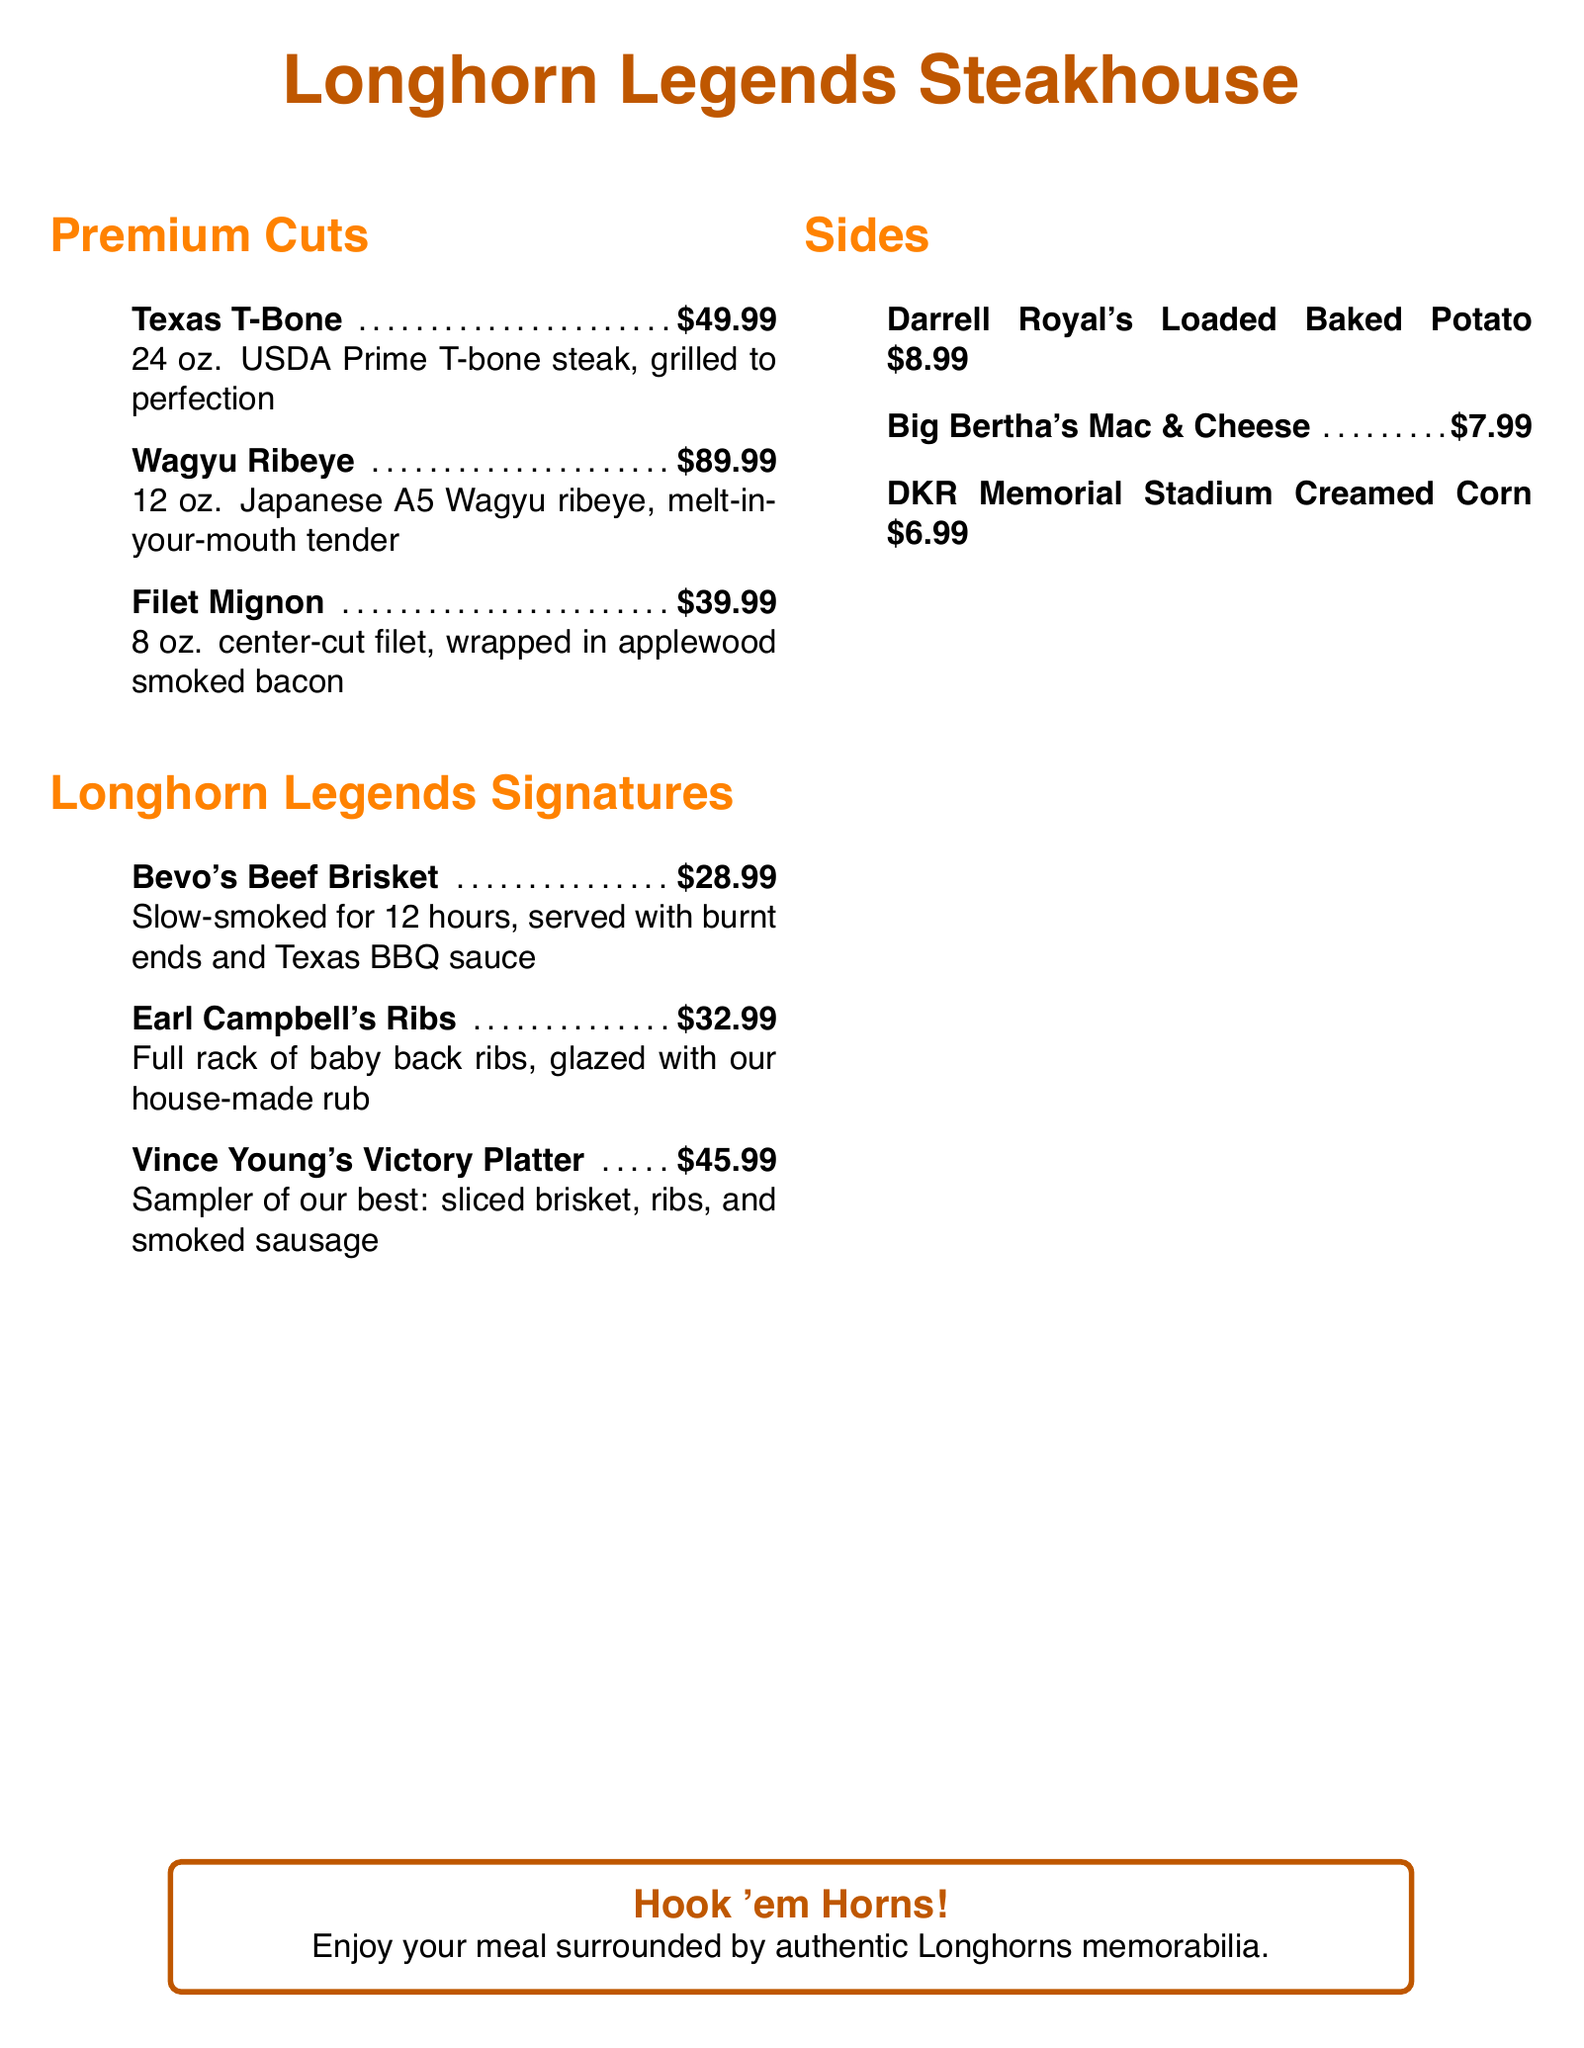what is the price of the Texas T-Bone? The price of the Texas T-Bone is listed in the menu under Premium Cuts.
Answer: $49.99 how many ounces is the Wagyu Ribeye? The Wagyu Ribeye is mentioned in the menu with its specific weight.
Answer: 12 oz what is the main ingredient of Bevo's Beef Brisket? Bevo's Beef Brisket is described in the menu, listing its main ingredient.
Answer: Beef Brisket how many sides are listed in the menu? The number of sides can be counted from the Sides section of the menu.
Answer: 3 which signature dish is named after a former football player? The Longhorn Legends section includes dishes named after notable figures, identifying one that relates to a former athlete.
Answer: Earl Campbell's Ribs what is included in the Vince Young's Victory Platter? The description of Vince Young's Victory Platter provides information on what this dish contains.
Answer: Sliced brisket, ribs, and smoked sausage what color is used for the restaurant name? The color used for the restaurant name can be found in the title's styling.
Answer: Burnt orange which side dish is priced at $8.99? The price of Darrell Royal's Loaded Baked Potato is listed in the Sides section.
Answer: Darrell Royal's Loaded Baked Potato 